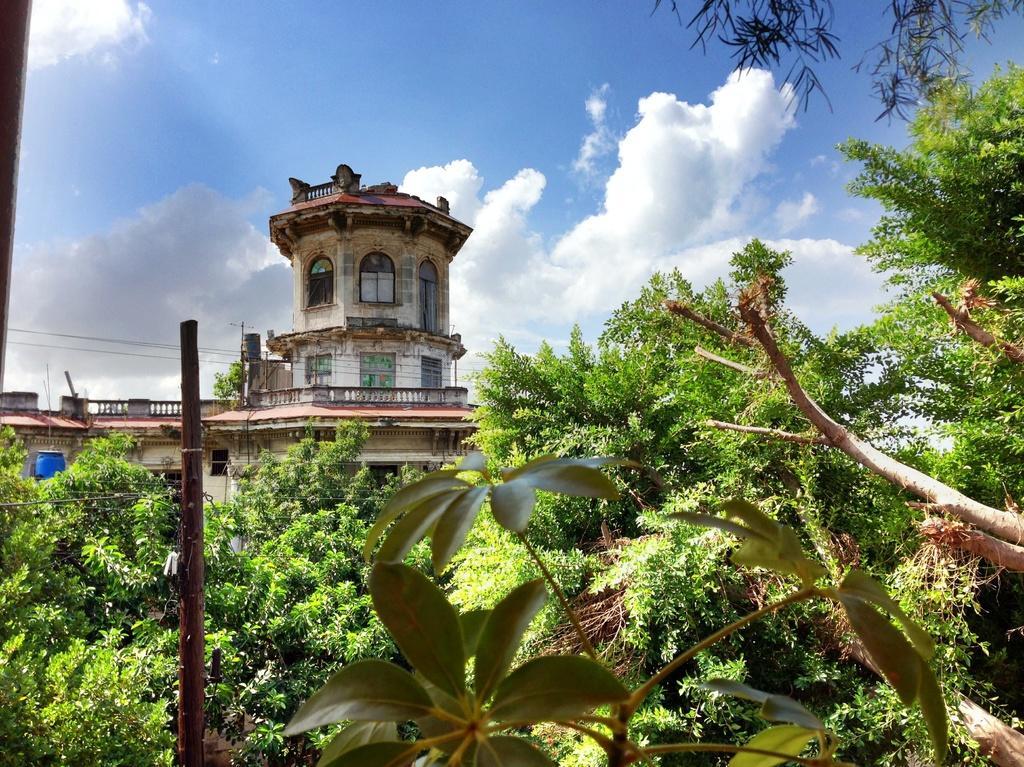In one or two sentences, can you explain what this image depicts? In this image I can see the plants, pole and the trees. In the background I can see the building, clouds and the sky. 